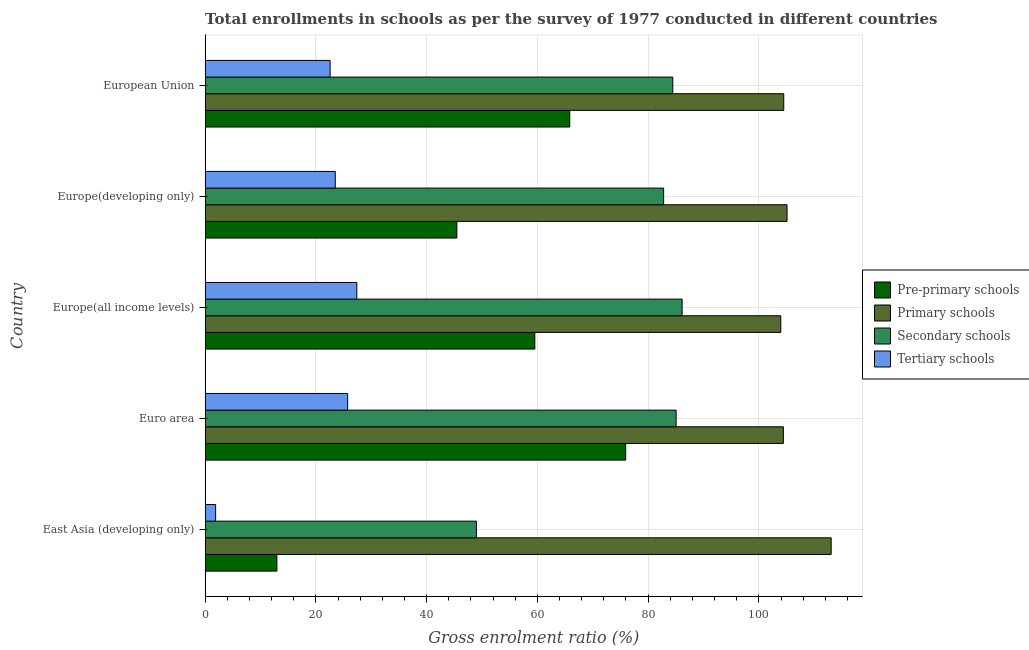How many different coloured bars are there?
Your answer should be compact. 4. What is the label of the 4th group of bars from the top?
Provide a short and direct response. Euro area. What is the gross enrolment ratio in secondary schools in European Union?
Make the answer very short. 84.45. Across all countries, what is the maximum gross enrolment ratio in primary schools?
Offer a terse response. 113.06. Across all countries, what is the minimum gross enrolment ratio in tertiary schools?
Offer a very short reply. 1.88. In which country was the gross enrolment ratio in secondary schools maximum?
Offer a terse response. Europe(all income levels). In which country was the gross enrolment ratio in primary schools minimum?
Ensure brevity in your answer.  Europe(all income levels). What is the total gross enrolment ratio in tertiary schools in the graph?
Provide a short and direct response. 101.05. What is the difference between the gross enrolment ratio in tertiary schools in East Asia (developing only) and that in Euro area?
Your answer should be compact. -23.85. What is the difference between the gross enrolment ratio in pre-primary schools in Europe(all income levels) and the gross enrolment ratio in secondary schools in East Asia (developing only)?
Offer a very short reply. 10.55. What is the average gross enrolment ratio in primary schools per country?
Keep it short and to the point. 106.21. What is the difference between the gross enrolment ratio in tertiary schools and gross enrolment ratio in pre-primary schools in European Union?
Your answer should be compact. -43.28. What is the ratio of the gross enrolment ratio in secondary schools in Euro area to that in Europe(developing only)?
Give a very brief answer. 1.03. Is the difference between the gross enrolment ratio in tertiary schools in Euro area and Europe(developing only) greater than the difference between the gross enrolment ratio in pre-primary schools in Euro area and Europe(developing only)?
Offer a very short reply. No. What is the difference between the highest and the second highest gross enrolment ratio in primary schools?
Provide a short and direct response. 7.97. What is the difference between the highest and the lowest gross enrolment ratio in secondary schools?
Provide a succinct answer. 37.15. Is it the case that in every country, the sum of the gross enrolment ratio in pre-primary schools and gross enrolment ratio in secondary schools is greater than the sum of gross enrolment ratio in primary schools and gross enrolment ratio in tertiary schools?
Give a very brief answer. No. What does the 4th bar from the top in Europe(all income levels) represents?
Offer a terse response. Pre-primary schools. What does the 1st bar from the bottom in East Asia (developing only) represents?
Provide a succinct answer. Pre-primary schools. Is it the case that in every country, the sum of the gross enrolment ratio in pre-primary schools and gross enrolment ratio in primary schools is greater than the gross enrolment ratio in secondary schools?
Offer a very short reply. Yes. Are all the bars in the graph horizontal?
Keep it short and to the point. Yes. How many countries are there in the graph?
Give a very brief answer. 5. What is the difference between two consecutive major ticks on the X-axis?
Ensure brevity in your answer.  20. Are the values on the major ticks of X-axis written in scientific E-notation?
Your answer should be compact. No. Does the graph contain any zero values?
Provide a succinct answer. No. How many legend labels are there?
Your answer should be compact. 4. What is the title of the graph?
Your answer should be very brief. Total enrollments in schools as per the survey of 1977 conducted in different countries. Does "Taxes on goods and services" appear as one of the legend labels in the graph?
Make the answer very short. No. What is the label or title of the Y-axis?
Offer a very short reply. Country. What is the Gross enrolment ratio (%) of Pre-primary schools in East Asia (developing only)?
Offer a terse response. 12.95. What is the Gross enrolment ratio (%) of Primary schools in East Asia (developing only)?
Make the answer very short. 113.06. What is the Gross enrolment ratio (%) of Secondary schools in East Asia (developing only)?
Your answer should be very brief. 48.99. What is the Gross enrolment ratio (%) in Tertiary schools in East Asia (developing only)?
Ensure brevity in your answer.  1.88. What is the Gross enrolment ratio (%) of Pre-primary schools in Euro area?
Your answer should be very brief. 75.94. What is the Gross enrolment ratio (%) in Primary schools in Euro area?
Your answer should be compact. 104.43. What is the Gross enrolment ratio (%) of Secondary schools in Euro area?
Keep it short and to the point. 85.06. What is the Gross enrolment ratio (%) in Tertiary schools in Euro area?
Offer a terse response. 25.73. What is the Gross enrolment ratio (%) of Pre-primary schools in Europe(all income levels)?
Your response must be concise. 59.53. What is the Gross enrolment ratio (%) in Primary schools in Europe(all income levels)?
Offer a terse response. 103.96. What is the Gross enrolment ratio (%) of Secondary schools in Europe(all income levels)?
Your answer should be compact. 86.14. What is the Gross enrolment ratio (%) in Tertiary schools in Europe(all income levels)?
Provide a succinct answer. 27.38. What is the Gross enrolment ratio (%) in Pre-primary schools in Europe(developing only)?
Your answer should be very brief. 45.45. What is the Gross enrolment ratio (%) of Primary schools in Europe(developing only)?
Offer a very short reply. 105.09. What is the Gross enrolment ratio (%) of Secondary schools in Europe(developing only)?
Offer a very short reply. 82.8. What is the Gross enrolment ratio (%) in Tertiary schools in Europe(developing only)?
Your response must be concise. 23.49. What is the Gross enrolment ratio (%) in Pre-primary schools in European Union?
Ensure brevity in your answer.  65.85. What is the Gross enrolment ratio (%) of Primary schools in European Union?
Your answer should be very brief. 104.5. What is the Gross enrolment ratio (%) of Secondary schools in European Union?
Give a very brief answer. 84.45. What is the Gross enrolment ratio (%) of Tertiary schools in European Union?
Offer a terse response. 22.56. Across all countries, what is the maximum Gross enrolment ratio (%) of Pre-primary schools?
Provide a short and direct response. 75.94. Across all countries, what is the maximum Gross enrolment ratio (%) in Primary schools?
Give a very brief answer. 113.06. Across all countries, what is the maximum Gross enrolment ratio (%) of Secondary schools?
Give a very brief answer. 86.14. Across all countries, what is the maximum Gross enrolment ratio (%) in Tertiary schools?
Provide a short and direct response. 27.38. Across all countries, what is the minimum Gross enrolment ratio (%) in Pre-primary schools?
Ensure brevity in your answer.  12.95. Across all countries, what is the minimum Gross enrolment ratio (%) in Primary schools?
Make the answer very short. 103.96. Across all countries, what is the minimum Gross enrolment ratio (%) of Secondary schools?
Your response must be concise. 48.99. Across all countries, what is the minimum Gross enrolment ratio (%) of Tertiary schools?
Your response must be concise. 1.88. What is the total Gross enrolment ratio (%) of Pre-primary schools in the graph?
Keep it short and to the point. 259.72. What is the total Gross enrolment ratio (%) of Primary schools in the graph?
Your answer should be very brief. 531.04. What is the total Gross enrolment ratio (%) in Secondary schools in the graph?
Offer a terse response. 387.44. What is the total Gross enrolment ratio (%) of Tertiary schools in the graph?
Offer a terse response. 101.05. What is the difference between the Gross enrolment ratio (%) of Pre-primary schools in East Asia (developing only) and that in Euro area?
Offer a terse response. -62.99. What is the difference between the Gross enrolment ratio (%) in Primary schools in East Asia (developing only) and that in Euro area?
Ensure brevity in your answer.  8.63. What is the difference between the Gross enrolment ratio (%) of Secondary schools in East Asia (developing only) and that in Euro area?
Your answer should be very brief. -36.07. What is the difference between the Gross enrolment ratio (%) in Tertiary schools in East Asia (developing only) and that in Euro area?
Give a very brief answer. -23.85. What is the difference between the Gross enrolment ratio (%) in Pre-primary schools in East Asia (developing only) and that in Europe(all income levels)?
Your answer should be compact. -46.58. What is the difference between the Gross enrolment ratio (%) in Primary schools in East Asia (developing only) and that in Europe(all income levels)?
Keep it short and to the point. 9.1. What is the difference between the Gross enrolment ratio (%) of Secondary schools in East Asia (developing only) and that in Europe(all income levels)?
Provide a short and direct response. -37.15. What is the difference between the Gross enrolment ratio (%) of Tertiary schools in East Asia (developing only) and that in Europe(all income levels)?
Keep it short and to the point. -25.5. What is the difference between the Gross enrolment ratio (%) in Pre-primary schools in East Asia (developing only) and that in Europe(developing only)?
Make the answer very short. -32.5. What is the difference between the Gross enrolment ratio (%) of Primary schools in East Asia (developing only) and that in Europe(developing only)?
Your response must be concise. 7.97. What is the difference between the Gross enrolment ratio (%) of Secondary schools in East Asia (developing only) and that in Europe(developing only)?
Your response must be concise. -33.81. What is the difference between the Gross enrolment ratio (%) in Tertiary schools in East Asia (developing only) and that in Europe(developing only)?
Offer a terse response. -21.61. What is the difference between the Gross enrolment ratio (%) in Pre-primary schools in East Asia (developing only) and that in European Union?
Offer a terse response. -52.9. What is the difference between the Gross enrolment ratio (%) in Primary schools in East Asia (developing only) and that in European Union?
Your response must be concise. 8.57. What is the difference between the Gross enrolment ratio (%) in Secondary schools in East Asia (developing only) and that in European Union?
Keep it short and to the point. -35.47. What is the difference between the Gross enrolment ratio (%) in Tertiary schools in East Asia (developing only) and that in European Union?
Keep it short and to the point. -20.68. What is the difference between the Gross enrolment ratio (%) in Pre-primary schools in Euro area and that in Europe(all income levels)?
Ensure brevity in your answer.  16.41. What is the difference between the Gross enrolment ratio (%) of Primary schools in Euro area and that in Europe(all income levels)?
Keep it short and to the point. 0.47. What is the difference between the Gross enrolment ratio (%) of Secondary schools in Euro area and that in Europe(all income levels)?
Your answer should be compact. -1.08. What is the difference between the Gross enrolment ratio (%) in Tertiary schools in Euro area and that in Europe(all income levels)?
Your answer should be compact. -1.66. What is the difference between the Gross enrolment ratio (%) of Pre-primary schools in Euro area and that in Europe(developing only)?
Make the answer very short. 30.49. What is the difference between the Gross enrolment ratio (%) of Primary schools in Euro area and that in Europe(developing only)?
Offer a terse response. -0.66. What is the difference between the Gross enrolment ratio (%) of Secondary schools in Euro area and that in Europe(developing only)?
Provide a succinct answer. 2.26. What is the difference between the Gross enrolment ratio (%) of Tertiary schools in Euro area and that in Europe(developing only)?
Offer a very short reply. 2.24. What is the difference between the Gross enrolment ratio (%) of Pre-primary schools in Euro area and that in European Union?
Offer a very short reply. 10.1. What is the difference between the Gross enrolment ratio (%) in Primary schools in Euro area and that in European Union?
Your answer should be compact. -0.07. What is the difference between the Gross enrolment ratio (%) in Secondary schools in Euro area and that in European Union?
Give a very brief answer. 0.6. What is the difference between the Gross enrolment ratio (%) in Tertiary schools in Euro area and that in European Union?
Your answer should be compact. 3.17. What is the difference between the Gross enrolment ratio (%) of Pre-primary schools in Europe(all income levels) and that in Europe(developing only)?
Offer a terse response. 14.08. What is the difference between the Gross enrolment ratio (%) of Primary schools in Europe(all income levels) and that in Europe(developing only)?
Ensure brevity in your answer.  -1.13. What is the difference between the Gross enrolment ratio (%) in Secondary schools in Europe(all income levels) and that in Europe(developing only)?
Keep it short and to the point. 3.34. What is the difference between the Gross enrolment ratio (%) of Tertiary schools in Europe(all income levels) and that in Europe(developing only)?
Your answer should be very brief. 3.89. What is the difference between the Gross enrolment ratio (%) of Pre-primary schools in Europe(all income levels) and that in European Union?
Your answer should be compact. -6.31. What is the difference between the Gross enrolment ratio (%) of Primary schools in Europe(all income levels) and that in European Union?
Make the answer very short. -0.54. What is the difference between the Gross enrolment ratio (%) of Secondary schools in Europe(all income levels) and that in European Union?
Ensure brevity in your answer.  1.68. What is the difference between the Gross enrolment ratio (%) in Tertiary schools in Europe(all income levels) and that in European Union?
Ensure brevity in your answer.  4.82. What is the difference between the Gross enrolment ratio (%) of Pre-primary schools in Europe(developing only) and that in European Union?
Make the answer very short. -20.4. What is the difference between the Gross enrolment ratio (%) of Primary schools in Europe(developing only) and that in European Union?
Your answer should be very brief. 0.59. What is the difference between the Gross enrolment ratio (%) in Secondary schools in Europe(developing only) and that in European Union?
Offer a very short reply. -1.66. What is the difference between the Gross enrolment ratio (%) of Tertiary schools in Europe(developing only) and that in European Union?
Offer a terse response. 0.93. What is the difference between the Gross enrolment ratio (%) of Pre-primary schools in East Asia (developing only) and the Gross enrolment ratio (%) of Primary schools in Euro area?
Offer a very short reply. -91.48. What is the difference between the Gross enrolment ratio (%) of Pre-primary schools in East Asia (developing only) and the Gross enrolment ratio (%) of Secondary schools in Euro area?
Keep it short and to the point. -72.11. What is the difference between the Gross enrolment ratio (%) in Pre-primary schools in East Asia (developing only) and the Gross enrolment ratio (%) in Tertiary schools in Euro area?
Give a very brief answer. -12.78. What is the difference between the Gross enrolment ratio (%) of Primary schools in East Asia (developing only) and the Gross enrolment ratio (%) of Secondary schools in Euro area?
Ensure brevity in your answer.  28. What is the difference between the Gross enrolment ratio (%) of Primary schools in East Asia (developing only) and the Gross enrolment ratio (%) of Tertiary schools in Euro area?
Make the answer very short. 87.33. What is the difference between the Gross enrolment ratio (%) of Secondary schools in East Asia (developing only) and the Gross enrolment ratio (%) of Tertiary schools in Euro area?
Make the answer very short. 23.26. What is the difference between the Gross enrolment ratio (%) in Pre-primary schools in East Asia (developing only) and the Gross enrolment ratio (%) in Primary schools in Europe(all income levels)?
Keep it short and to the point. -91.01. What is the difference between the Gross enrolment ratio (%) in Pre-primary schools in East Asia (developing only) and the Gross enrolment ratio (%) in Secondary schools in Europe(all income levels)?
Provide a short and direct response. -73.19. What is the difference between the Gross enrolment ratio (%) of Pre-primary schools in East Asia (developing only) and the Gross enrolment ratio (%) of Tertiary schools in Europe(all income levels)?
Provide a short and direct response. -14.44. What is the difference between the Gross enrolment ratio (%) in Primary schools in East Asia (developing only) and the Gross enrolment ratio (%) in Secondary schools in Europe(all income levels)?
Your response must be concise. 26.92. What is the difference between the Gross enrolment ratio (%) of Primary schools in East Asia (developing only) and the Gross enrolment ratio (%) of Tertiary schools in Europe(all income levels)?
Make the answer very short. 85.68. What is the difference between the Gross enrolment ratio (%) in Secondary schools in East Asia (developing only) and the Gross enrolment ratio (%) in Tertiary schools in Europe(all income levels)?
Provide a short and direct response. 21.6. What is the difference between the Gross enrolment ratio (%) in Pre-primary schools in East Asia (developing only) and the Gross enrolment ratio (%) in Primary schools in Europe(developing only)?
Make the answer very short. -92.14. What is the difference between the Gross enrolment ratio (%) of Pre-primary schools in East Asia (developing only) and the Gross enrolment ratio (%) of Secondary schools in Europe(developing only)?
Keep it short and to the point. -69.85. What is the difference between the Gross enrolment ratio (%) of Pre-primary schools in East Asia (developing only) and the Gross enrolment ratio (%) of Tertiary schools in Europe(developing only)?
Offer a terse response. -10.54. What is the difference between the Gross enrolment ratio (%) of Primary schools in East Asia (developing only) and the Gross enrolment ratio (%) of Secondary schools in Europe(developing only)?
Your response must be concise. 30.26. What is the difference between the Gross enrolment ratio (%) of Primary schools in East Asia (developing only) and the Gross enrolment ratio (%) of Tertiary schools in Europe(developing only)?
Provide a succinct answer. 89.57. What is the difference between the Gross enrolment ratio (%) of Secondary schools in East Asia (developing only) and the Gross enrolment ratio (%) of Tertiary schools in Europe(developing only)?
Ensure brevity in your answer.  25.49. What is the difference between the Gross enrolment ratio (%) of Pre-primary schools in East Asia (developing only) and the Gross enrolment ratio (%) of Primary schools in European Union?
Offer a very short reply. -91.55. What is the difference between the Gross enrolment ratio (%) of Pre-primary schools in East Asia (developing only) and the Gross enrolment ratio (%) of Secondary schools in European Union?
Offer a terse response. -71.5. What is the difference between the Gross enrolment ratio (%) in Pre-primary schools in East Asia (developing only) and the Gross enrolment ratio (%) in Tertiary schools in European Union?
Give a very brief answer. -9.61. What is the difference between the Gross enrolment ratio (%) in Primary schools in East Asia (developing only) and the Gross enrolment ratio (%) in Secondary schools in European Union?
Ensure brevity in your answer.  28.61. What is the difference between the Gross enrolment ratio (%) in Primary schools in East Asia (developing only) and the Gross enrolment ratio (%) in Tertiary schools in European Union?
Offer a very short reply. 90.5. What is the difference between the Gross enrolment ratio (%) of Secondary schools in East Asia (developing only) and the Gross enrolment ratio (%) of Tertiary schools in European Union?
Offer a very short reply. 26.42. What is the difference between the Gross enrolment ratio (%) of Pre-primary schools in Euro area and the Gross enrolment ratio (%) of Primary schools in Europe(all income levels)?
Give a very brief answer. -28.02. What is the difference between the Gross enrolment ratio (%) in Pre-primary schools in Euro area and the Gross enrolment ratio (%) in Secondary schools in Europe(all income levels)?
Your answer should be very brief. -10.19. What is the difference between the Gross enrolment ratio (%) in Pre-primary schools in Euro area and the Gross enrolment ratio (%) in Tertiary schools in Europe(all income levels)?
Ensure brevity in your answer.  48.56. What is the difference between the Gross enrolment ratio (%) of Primary schools in Euro area and the Gross enrolment ratio (%) of Secondary schools in Europe(all income levels)?
Your response must be concise. 18.29. What is the difference between the Gross enrolment ratio (%) in Primary schools in Euro area and the Gross enrolment ratio (%) in Tertiary schools in Europe(all income levels)?
Your answer should be very brief. 77.04. What is the difference between the Gross enrolment ratio (%) of Secondary schools in Euro area and the Gross enrolment ratio (%) of Tertiary schools in Europe(all income levels)?
Your answer should be compact. 57.67. What is the difference between the Gross enrolment ratio (%) in Pre-primary schools in Euro area and the Gross enrolment ratio (%) in Primary schools in Europe(developing only)?
Your answer should be very brief. -29.15. What is the difference between the Gross enrolment ratio (%) of Pre-primary schools in Euro area and the Gross enrolment ratio (%) of Secondary schools in Europe(developing only)?
Keep it short and to the point. -6.85. What is the difference between the Gross enrolment ratio (%) of Pre-primary schools in Euro area and the Gross enrolment ratio (%) of Tertiary schools in Europe(developing only)?
Make the answer very short. 52.45. What is the difference between the Gross enrolment ratio (%) of Primary schools in Euro area and the Gross enrolment ratio (%) of Secondary schools in Europe(developing only)?
Your answer should be compact. 21.63. What is the difference between the Gross enrolment ratio (%) in Primary schools in Euro area and the Gross enrolment ratio (%) in Tertiary schools in Europe(developing only)?
Provide a short and direct response. 80.94. What is the difference between the Gross enrolment ratio (%) in Secondary schools in Euro area and the Gross enrolment ratio (%) in Tertiary schools in Europe(developing only)?
Make the answer very short. 61.56. What is the difference between the Gross enrolment ratio (%) in Pre-primary schools in Euro area and the Gross enrolment ratio (%) in Primary schools in European Union?
Provide a short and direct response. -28.55. What is the difference between the Gross enrolment ratio (%) of Pre-primary schools in Euro area and the Gross enrolment ratio (%) of Secondary schools in European Union?
Ensure brevity in your answer.  -8.51. What is the difference between the Gross enrolment ratio (%) of Pre-primary schools in Euro area and the Gross enrolment ratio (%) of Tertiary schools in European Union?
Make the answer very short. 53.38. What is the difference between the Gross enrolment ratio (%) in Primary schools in Euro area and the Gross enrolment ratio (%) in Secondary schools in European Union?
Your answer should be very brief. 19.97. What is the difference between the Gross enrolment ratio (%) in Primary schools in Euro area and the Gross enrolment ratio (%) in Tertiary schools in European Union?
Your answer should be compact. 81.87. What is the difference between the Gross enrolment ratio (%) in Secondary schools in Euro area and the Gross enrolment ratio (%) in Tertiary schools in European Union?
Provide a succinct answer. 62.5. What is the difference between the Gross enrolment ratio (%) of Pre-primary schools in Europe(all income levels) and the Gross enrolment ratio (%) of Primary schools in Europe(developing only)?
Your answer should be very brief. -45.56. What is the difference between the Gross enrolment ratio (%) of Pre-primary schools in Europe(all income levels) and the Gross enrolment ratio (%) of Secondary schools in Europe(developing only)?
Make the answer very short. -23.27. What is the difference between the Gross enrolment ratio (%) in Pre-primary schools in Europe(all income levels) and the Gross enrolment ratio (%) in Tertiary schools in Europe(developing only)?
Offer a very short reply. 36.04. What is the difference between the Gross enrolment ratio (%) in Primary schools in Europe(all income levels) and the Gross enrolment ratio (%) in Secondary schools in Europe(developing only)?
Your answer should be very brief. 21.16. What is the difference between the Gross enrolment ratio (%) of Primary schools in Europe(all income levels) and the Gross enrolment ratio (%) of Tertiary schools in Europe(developing only)?
Your response must be concise. 80.47. What is the difference between the Gross enrolment ratio (%) in Secondary schools in Europe(all income levels) and the Gross enrolment ratio (%) in Tertiary schools in Europe(developing only)?
Offer a terse response. 62.65. What is the difference between the Gross enrolment ratio (%) of Pre-primary schools in Europe(all income levels) and the Gross enrolment ratio (%) of Primary schools in European Union?
Offer a terse response. -44.96. What is the difference between the Gross enrolment ratio (%) in Pre-primary schools in Europe(all income levels) and the Gross enrolment ratio (%) in Secondary schools in European Union?
Provide a short and direct response. -24.92. What is the difference between the Gross enrolment ratio (%) of Pre-primary schools in Europe(all income levels) and the Gross enrolment ratio (%) of Tertiary schools in European Union?
Your response must be concise. 36.97. What is the difference between the Gross enrolment ratio (%) in Primary schools in Europe(all income levels) and the Gross enrolment ratio (%) in Secondary schools in European Union?
Keep it short and to the point. 19.51. What is the difference between the Gross enrolment ratio (%) in Primary schools in Europe(all income levels) and the Gross enrolment ratio (%) in Tertiary schools in European Union?
Ensure brevity in your answer.  81.4. What is the difference between the Gross enrolment ratio (%) in Secondary schools in Europe(all income levels) and the Gross enrolment ratio (%) in Tertiary schools in European Union?
Your answer should be compact. 63.58. What is the difference between the Gross enrolment ratio (%) of Pre-primary schools in Europe(developing only) and the Gross enrolment ratio (%) of Primary schools in European Union?
Your answer should be compact. -59.05. What is the difference between the Gross enrolment ratio (%) of Pre-primary schools in Europe(developing only) and the Gross enrolment ratio (%) of Secondary schools in European Union?
Keep it short and to the point. -39. What is the difference between the Gross enrolment ratio (%) of Pre-primary schools in Europe(developing only) and the Gross enrolment ratio (%) of Tertiary schools in European Union?
Keep it short and to the point. 22.89. What is the difference between the Gross enrolment ratio (%) of Primary schools in Europe(developing only) and the Gross enrolment ratio (%) of Secondary schools in European Union?
Make the answer very short. 20.64. What is the difference between the Gross enrolment ratio (%) of Primary schools in Europe(developing only) and the Gross enrolment ratio (%) of Tertiary schools in European Union?
Provide a succinct answer. 82.53. What is the difference between the Gross enrolment ratio (%) of Secondary schools in Europe(developing only) and the Gross enrolment ratio (%) of Tertiary schools in European Union?
Your answer should be compact. 60.24. What is the average Gross enrolment ratio (%) in Pre-primary schools per country?
Keep it short and to the point. 51.94. What is the average Gross enrolment ratio (%) of Primary schools per country?
Offer a very short reply. 106.21. What is the average Gross enrolment ratio (%) of Secondary schools per country?
Provide a short and direct response. 77.49. What is the average Gross enrolment ratio (%) in Tertiary schools per country?
Your answer should be very brief. 20.21. What is the difference between the Gross enrolment ratio (%) of Pre-primary schools and Gross enrolment ratio (%) of Primary schools in East Asia (developing only)?
Ensure brevity in your answer.  -100.11. What is the difference between the Gross enrolment ratio (%) of Pre-primary schools and Gross enrolment ratio (%) of Secondary schools in East Asia (developing only)?
Your answer should be compact. -36.04. What is the difference between the Gross enrolment ratio (%) in Pre-primary schools and Gross enrolment ratio (%) in Tertiary schools in East Asia (developing only)?
Your response must be concise. 11.07. What is the difference between the Gross enrolment ratio (%) in Primary schools and Gross enrolment ratio (%) in Secondary schools in East Asia (developing only)?
Provide a succinct answer. 64.08. What is the difference between the Gross enrolment ratio (%) of Primary schools and Gross enrolment ratio (%) of Tertiary schools in East Asia (developing only)?
Make the answer very short. 111.18. What is the difference between the Gross enrolment ratio (%) in Secondary schools and Gross enrolment ratio (%) in Tertiary schools in East Asia (developing only)?
Your answer should be compact. 47.1. What is the difference between the Gross enrolment ratio (%) in Pre-primary schools and Gross enrolment ratio (%) in Primary schools in Euro area?
Provide a short and direct response. -28.48. What is the difference between the Gross enrolment ratio (%) of Pre-primary schools and Gross enrolment ratio (%) of Secondary schools in Euro area?
Your response must be concise. -9.11. What is the difference between the Gross enrolment ratio (%) of Pre-primary schools and Gross enrolment ratio (%) of Tertiary schools in Euro area?
Provide a short and direct response. 50.21. What is the difference between the Gross enrolment ratio (%) in Primary schools and Gross enrolment ratio (%) in Secondary schools in Euro area?
Provide a succinct answer. 19.37. What is the difference between the Gross enrolment ratio (%) in Primary schools and Gross enrolment ratio (%) in Tertiary schools in Euro area?
Offer a very short reply. 78.7. What is the difference between the Gross enrolment ratio (%) of Secondary schools and Gross enrolment ratio (%) of Tertiary schools in Euro area?
Provide a succinct answer. 59.33. What is the difference between the Gross enrolment ratio (%) of Pre-primary schools and Gross enrolment ratio (%) of Primary schools in Europe(all income levels)?
Provide a short and direct response. -44.43. What is the difference between the Gross enrolment ratio (%) of Pre-primary schools and Gross enrolment ratio (%) of Secondary schools in Europe(all income levels)?
Your answer should be very brief. -26.61. What is the difference between the Gross enrolment ratio (%) in Pre-primary schools and Gross enrolment ratio (%) in Tertiary schools in Europe(all income levels)?
Your answer should be compact. 32.15. What is the difference between the Gross enrolment ratio (%) of Primary schools and Gross enrolment ratio (%) of Secondary schools in Europe(all income levels)?
Offer a terse response. 17.82. What is the difference between the Gross enrolment ratio (%) of Primary schools and Gross enrolment ratio (%) of Tertiary schools in Europe(all income levels)?
Make the answer very short. 76.58. What is the difference between the Gross enrolment ratio (%) in Secondary schools and Gross enrolment ratio (%) in Tertiary schools in Europe(all income levels)?
Your answer should be very brief. 58.75. What is the difference between the Gross enrolment ratio (%) of Pre-primary schools and Gross enrolment ratio (%) of Primary schools in Europe(developing only)?
Offer a very short reply. -59.64. What is the difference between the Gross enrolment ratio (%) of Pre-primary schools and Gross enrolment ratio (%) of Secondary schools in Europe(developing only)?
Your response must be concise. -37.35. What is the difference between the Gross enrolment ratio (%) in Pre-primary schools and Gross enrolment ratio (%) in Tertiary schools in Europe(developing only)?
Your answer should be compact. 21.96. What is the difference between the Gross enrolment ratio (%) of Primary schools and Gross enrolment ratio (%) of Secondary schools in Europe(developing only)?
Provide a short and direct response. 22.29. What is the difference between the Gross enrolment ratio (%) of Primary schools and Gross enrolment ratio (%) of Tertiary schools in Europe(developing only)?
Give a very brief answer. 81.6. What is the difference between the Gross enrolment ratio (%) of Secondary schools and Gross enrolment ratio (%) of Tertiary schools in Europe(developing only)?
Your response must be concise. 59.31. What is the difference between the Gross enrolment ratio (%) of Pre-primary schools and Gross enrolment ratio (%) of Primary schools in European Union?
Offer a terse response. -38.65. What is the difference between the Gross enrolment ratio (%) in Pre-primary schools and Gross enrolment ratio (%) in Secondary schools in European Union?
Your answer should be very brief. -18.61. What is the difference between the Gross enrolment ratio (%) of Pre-primary schools and Gross enrolment ratio (%) of Tertiary schools in European Union?
Provide a succinct answer. 43.28. What is the difference between the Gross enrolment ratio (%) in Primary schools and Gross enrolment ratio (%) in Secondary schools in European Union?
Your response must be concise. 20.04. What is the difference between the Gross enrolment ratio (%) in Primary schools and Gross enrolment ratio (%) in Tertiary schools in European Union?
Offer a terse response. 81.93. What is the difference between the Gross enrolment ratio (%) in Secondary schools and Gross enrolment ratio (%) in Tertiary schools in European Union?
Provide a short and direct response. 61.89. What is the ratio of the Gross enrolment ratio (%) in Pre-primary schools in East Asia (developing only) to that in Euro area?
Make the answer very short. 0.17. What is the ratio of the Gross enrolment ratio (%) in Primary schools in East Asia (developing only) to that in Euro area?
Your answer should be compact. 1.08. What is the ratio of the Gross enrolment ratio (%) in Secondary schools in East Asia (developing only) to that in Euro area?
Provide a succinct answer. 0.58. What is the ratio of the Gross enrolment ratio (%) of Tertiary schools in East Asia (developing only) to that in Euro area?
Provide a short and direct response. 0.07. What is the ratio of the Gross enrolment ratio (%) of Pre-primary schools in East Asia (developing only) to that in Europe(all income levels)?
Your answer should be very brief. 0.22. What is the ratio of the Gross enrolment ratio (%) of Primary schools in East Asia (developing only) to that in Europe(all income levels)?
Provide a short and direct response. 1.09. What is the ratio of the Gross enrolment ratio (%) of Secondary schools in East Asia (developing only) to that in Europe(all income levels)?
Your response must be concise. 0.57. What is the ratio of the Gross enrolment ratio (%) in Tertiary schools in East Asia (developing only) to that in Europe(all income levels)?
Your response must be concise. 0.07. What is the ratio of the Gross enrolment ratio (%) in Pre-primary schools in East Asia (developing only) to that in Europe(developing only)?
Ensure brevity in your answer.  0.28. What is the ratio of the Gross enrolment ratio (%) in Primary schools in East Asia (developing only) to that in Europe(developing only)?
Your answer should be very brief. 1.08. What is the ratio of the Gross enrolment ratio (%) of Secondary schools in East Asia (developing only) to that in Europe(developing only)?
Provide a short and direct response. 0.59. What is the ratio of the Gross enrolment ratio (%) in Tertiary schools in East Asia (developing only) to that in Europe(developing only)?
Offer a very short reply. 0.08. What is the ratio of the Gross enrolment ratio (%) of Pre-primary schools in East Asia (developing only) to that in European Union?
Give a very brief answer. 0.2. What is the ratio of the Gross enrolment ratio (%) of Primary schools in East Asia (developing only) to that in European Union?
Your response must be concise. 1.08. What is the ratio of the Gross enrolment ratio (%) of Secondary schools in East Asia (developing only) to that in European Union?
Your answer should be very brief. 0.58. What is the ratio of the Gross enrolment ratio (%) of Tertiary schools in East Asia (developing only) to that in European Union?
Provide a succinct answer. 0.08. What is the ratio of the Gross enrolment ratio (%) of Pre-primary schools in Euro area to that in Europe(all income levels)?
Provide a short and direct response. 1.28. What is the ratio of the Gross enrolment ratio (%) of Primary schools in Euro area to that in Europe(all income levels)?
Give a very brief answer. 1. What is the ratio of the Gross enrolment ratio (%) in Secondary schools in Euro area to that in Europe(all income levels)?
Provide a short and direct response. 0.99. What is the ratio of the Gross enrolment ratio (%) of Tertiary schools in Euro area to that in Europe(all income levels)?
Make the answer very short. 0.94. What is the ratio of the Gross enrolment ratio (%) of Pre-primary schools in Euro area to that in Europe(developing only)?
Provide a short and direct response. 1.67. What is the ratio of the Gross enrolment ratio (%) of Primary schools in Euro area to that in Europe(developing only)?
Make the answer very short. 0.99. What is the ratio of the Gross enrolment ratio (%) of Secondary schools in Euro area to that in Europe(developing only)?
Ensure brevity in your answer.  1.03. What is the ratio of the Gross enrolment ratio (%) of Tertiary schools in Euro area to that in Europe(developing only)?
Provide a succinct answer. 1.1. What is the ratio of the Gross enrolment ratio (%) in Pre-primary schools in Euro area to that in European Union?
Ensure brevity in your answer.  1.15. What is the ratio of the Gross enrolment ratio (%) of Secondary schools in Euro area to that in European Union?
Your answer should be compact. 1.01. What is the ratio of the Gross enrolment ratio (%) in Tertiary schools in Euro area to that in European Union?
Make the answer very short. 1.14. What is the ratio of the Gross enrolment ratio (%) of Pre-primary schools in Europe(all income levels) to that in Europe(developing only)?
Offer a very short reply. 1.31. What is the ratio of the Gross enrolment ratio (%) in Secondary schools in Europe(all income levels) to that in Europe(developing only)?
Your answer should be compact. 1.04. What is the ratio of the Gross enrolment ratio (%) of Tertiary schools in Europe(all income levels) to that in Europe(developing only)?
Offer a very short reply. 1.17. What is the ratio of the Gross enrolment ratio (%) of Pre-primary schools in Europe(all income levels) to that in European Union?
Your answer should be compact. 0.9. What is the ratio of the Gross enrolment ratio (%) of Secondary schools in Europe(all income levels) to that in European Union?
Provide a succinct answer. 1.02. What is the ratio of the Gross enrolment ratio (%) in Tertiary schools in Europe(all income levels) to that in European Union?
Provide a succinct answer. 1.21. What is the ratio of the Gross enrolment ratio (%) in Pre-primary schools in Europe(developing only) to that in European Union?
Your answer should be compact. 0.69. What is the ratio of the Gross enrolment ratio (%) of Secondary schools in Europe(developing only) to that in European Union?
Ensure brevity in your answer.  0.98. What is the ratio of the Gross enrolment ratio (%) of Tertiary schools in Europe(developing only) to that in European Union?
Your response must be concise. 1.04. What is the difference between the highest and the second highest Gross enrolment ratio (%) in Pre-primary schools?
Provide a succinct answer. 10.1. What is the difference between the highest and the second highest Gross enrolment ratio (%) of Primary schools?
Your answer should be compact. 7.97. What is the difference between the highest and the second highest Gross enrolment ratio (%) in Secondary schools?
Ensure brevity in your answer.  1.08. What is the difference between the highest and the second highest Gross enrolment ratio (%) in Tertiary schools?
Make the answer very short. 1.66. What is the difference between the highest and the lowest Gross enrolment ratio (%) in Pre-primary schools?
Provide a succinct answer. 62.99. What is the difference between the highest and the lowest Gross enrolment ratio (%) in Primary schools?
Your response must be concise. 9.1. What is the difference between the highest and the lowest Gross enrolment ratio (%) in Secondary schools?
Your answer should be compact. 37.15. What is the difference between the highest and the lowest Gross enrolment ratio (%) in Tertiary schools?
Provide a succinct answer. 25.5. 